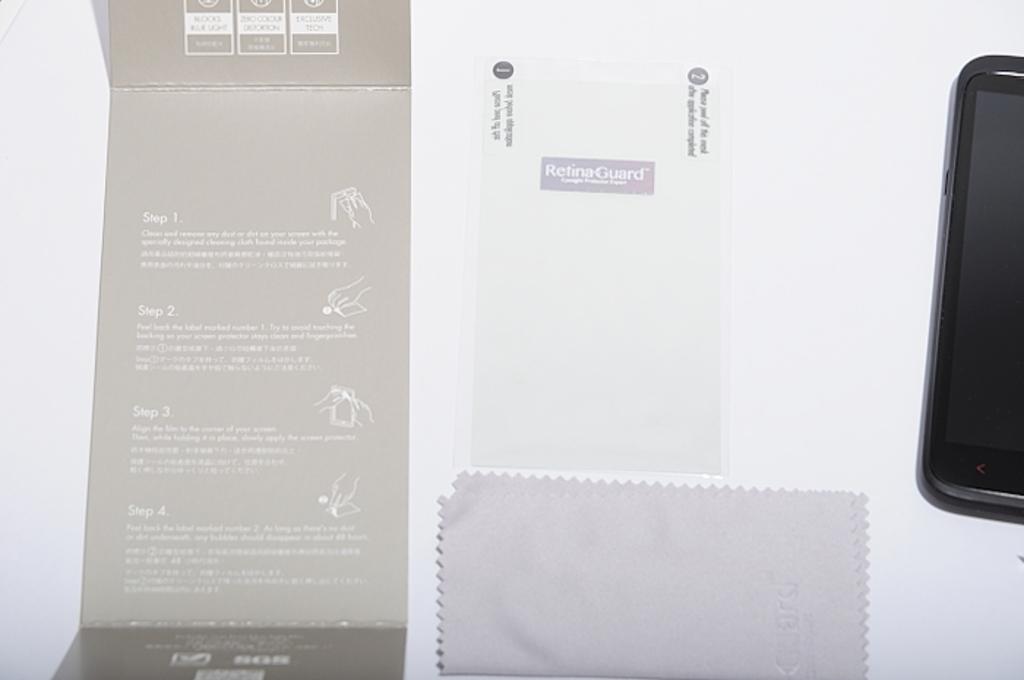What is the name of this screen protector?
Your response must be concise. Retinaguard. How many steps are listed on the packaging?
Keep it short and to the point. 4. 